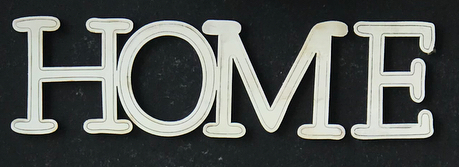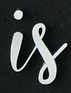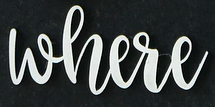What words can you see in these images in sequence, separated by a semicolon? HOME; is; where 